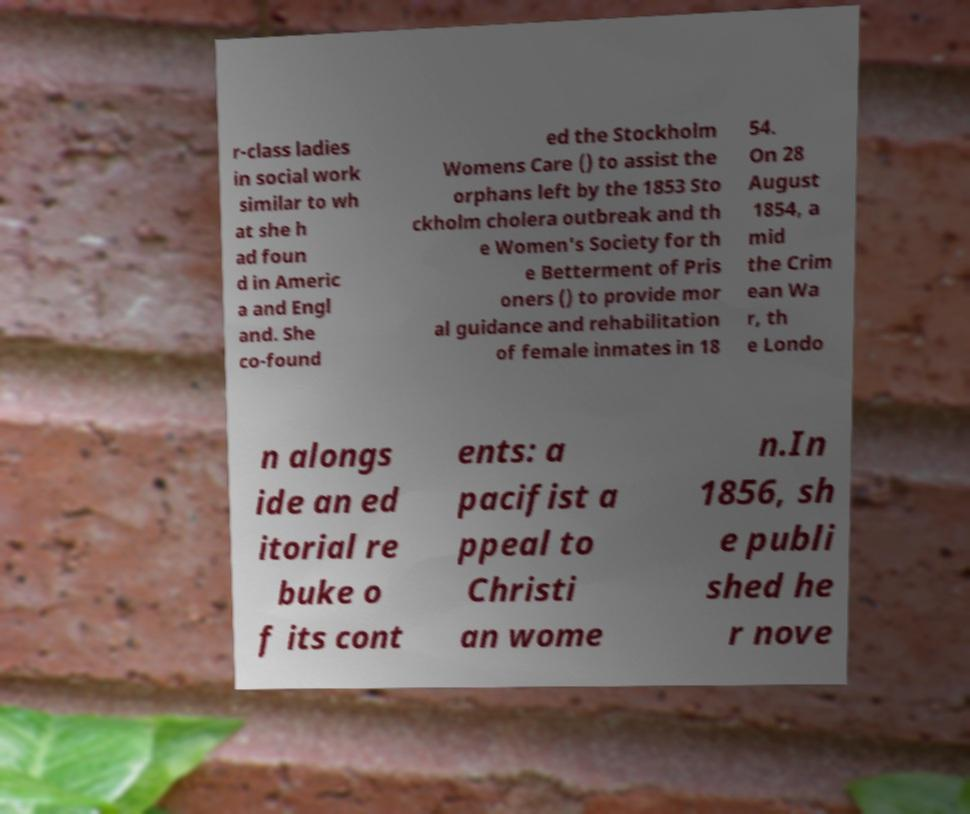Please read and relay the text visible in this image. What does it say? r-class ladies in social work similar to wh at she h ad foun d in Americ a and Engl and. She co-found ed the Stockholm Womens Care () to assist the orphans left by the 1853 Sto ckholm cholera outbreak and th e Women's Society for th e Betterment of Pris oners () to provide mor al guidance and rehabilitation of female inmates in 18 54. On 28 August 1854, a mid the Crim ean Wa r, th e Londo n alongs ide an ed itorial re buke o f its cont ents: a pacifist a ppeal to Christi an wome n.In 1856, sh e publi shed he r nove 